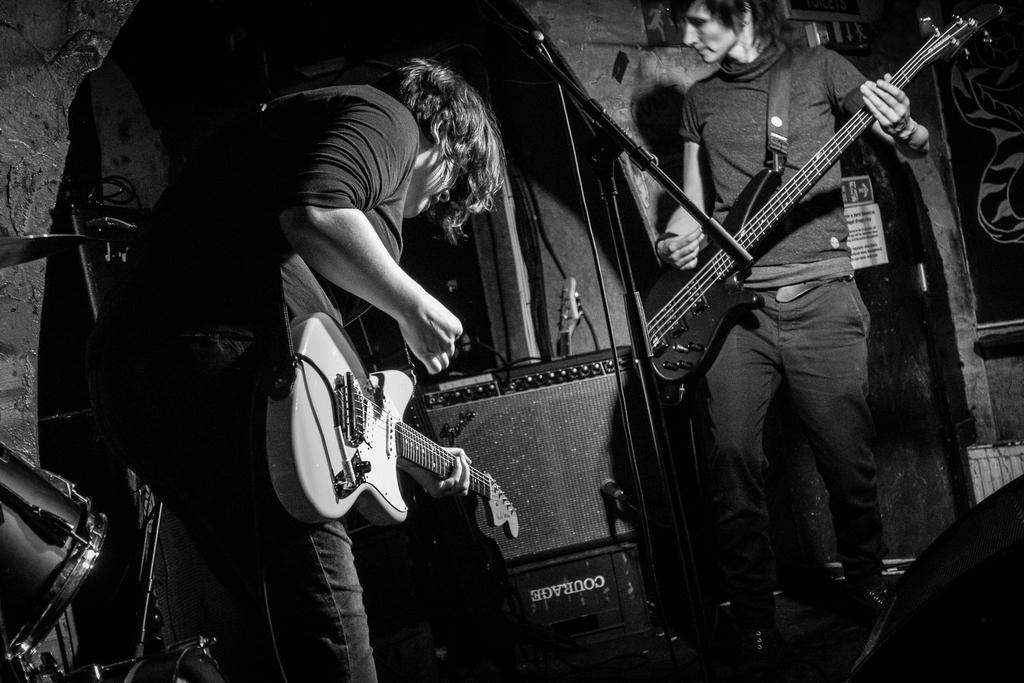How many people are in the image? There are two men in the image. What are the two men doing in the image? The two men are playing a guitar. Can you identify any other musical instruments in the image? Yes, there is a drum in the image. How many cows are visible in the image? There are no cows present in the image. What color are the eyes of the guitar in the image? The image does not depict the eyes of the guitar, as guitars do not have eyes. 